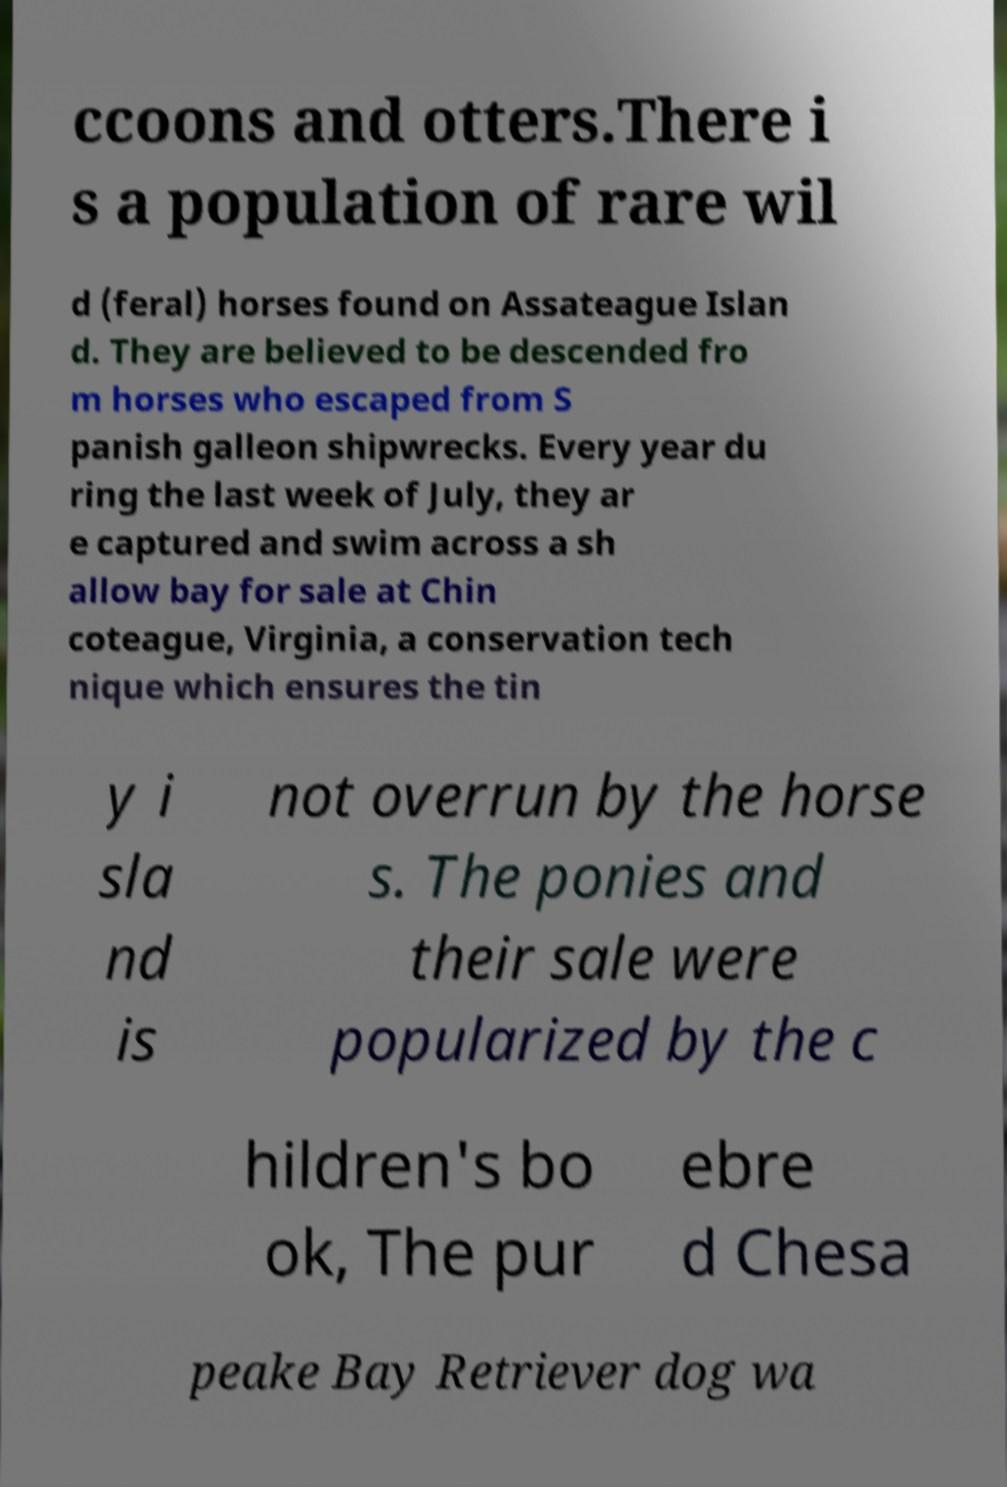There's text embedded in this image that I need extracted. Can you transcribe it verbatim? ccoons and otters.There i s a population of rare wil d (feral) horses found on Assateague Islan d. They are believed to be descended fro m horses who escaped from S panish galleon shipwrecks. Every year du ring the last week of July, they ar e captured and swim across a sh allow bay for sale at Chin coteague, Virginia, a conservation tech nique which ensures the tin y i sla nd is not overrun by the horse s. The ponies and their sale were popularized by the c hildren's bo ok, The pur ebre d Chesa peake Bay Retriever dog wa 